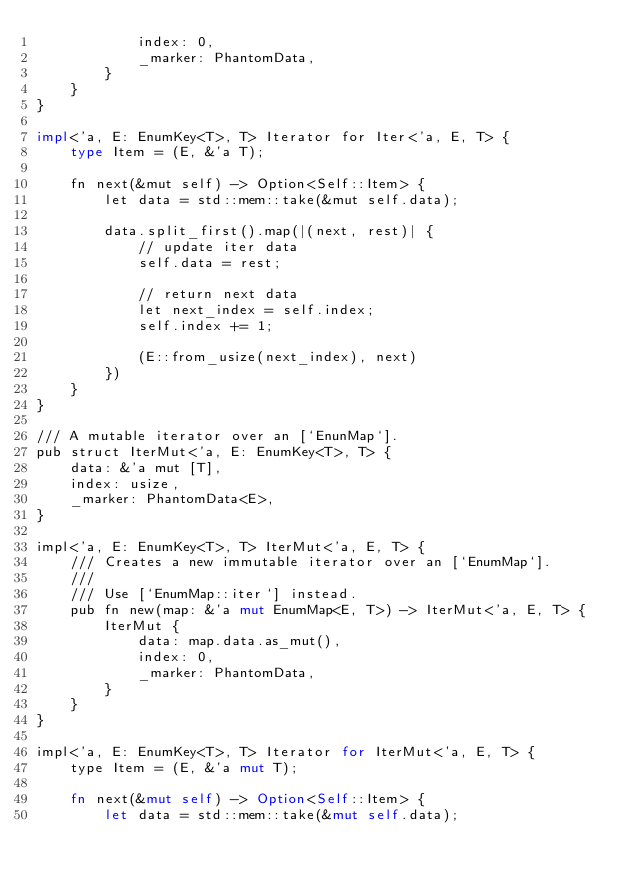Convert code to text. <code><loc_0><loc_0><loc_500><loc_500><_Rust_>            index: 0,
            _marker: PhantomData,
        }
    }
}

impl<'a, E: EnumKey<T>, T> Iterator for Iter<'a, E, T> {
    type Item = (E, &'a T);

    fn next(&mut self) -> Option<Self::Item> {
        let data = std::mem::take(&mut self.data);

        data.split_first().map(|(next, rest)| {
            // update iter data
            self.data = rest;

            // return next data
            let next_index = self.index;
            self.index += 1;

            (E::from_usize(next_index), next)
        })
    }
}

/// A mutable iterator over an [`EnunMap`].
pub struct IterMut<'a, E: EnumKey<T>, T> {
    data: &'a mut [T],
    index: usize,
    _marker: PhantomData<E>,
}

impl<'a, E: EnumKey<T>, T> IterMut<'a, E, T> {
    /// Creates a new immutable iterator over an [`EnumMap`].
    ///
    /// Use [`EnumMap::iter`] instead.
    pub fn new(map: &'a mut EnumMap<E, T>) -> IterMut<'a, E, T> {
        IterMut {
            data: map.data.as_mut(),
            index: 0,
            _marker: PhantomData,
        }
    }
}

impl<'a, E: EnumKey<T>, T> Iterator for IterMut<'a, E, T> {
    type Item = (E, &'a mut T);

    fn next(&mut self) -> Option<Self::Item> {
        let data = std::mem::take(&mut self.data);
</code> 